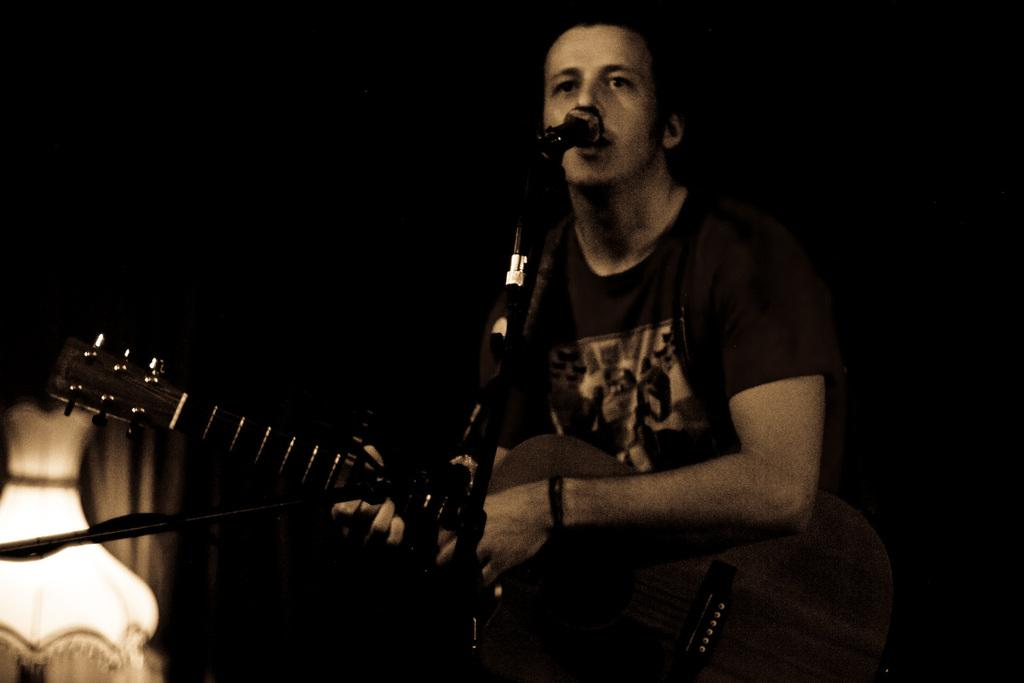What is the man in the image doing? The man is singing and playing a guitar. What instrument is the man playing in the image? The man is playing a guitar. What type of division is the man performing in the image? There is no division being performed in the image; the man is singing and playing a guitar. 